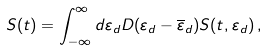Convert formula to latex. <formula><loc_0><loc_0><loc_500><loc_500>S ( t ) = \int _ { - \infty } ^ { \infty } d \varepsilon _ { d } D ( \varepsilon _ { d } - \overline { \varepsilon } _ { d } ) S ( t , \varepsilon _ { d } ) \, ,</formula> 